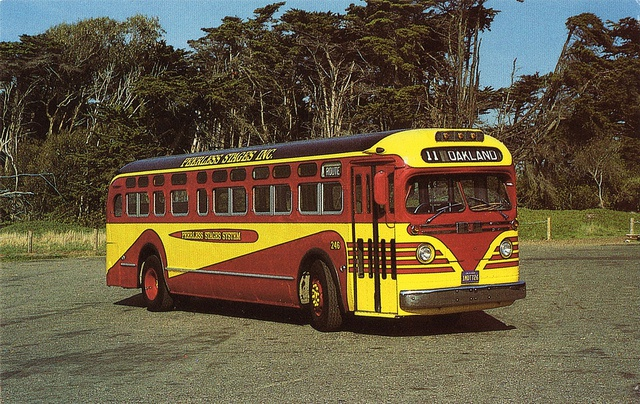Describe the objects in this image and their specific colors. I can see bus in white, black, maroon, brown, and gold tones in this image. 